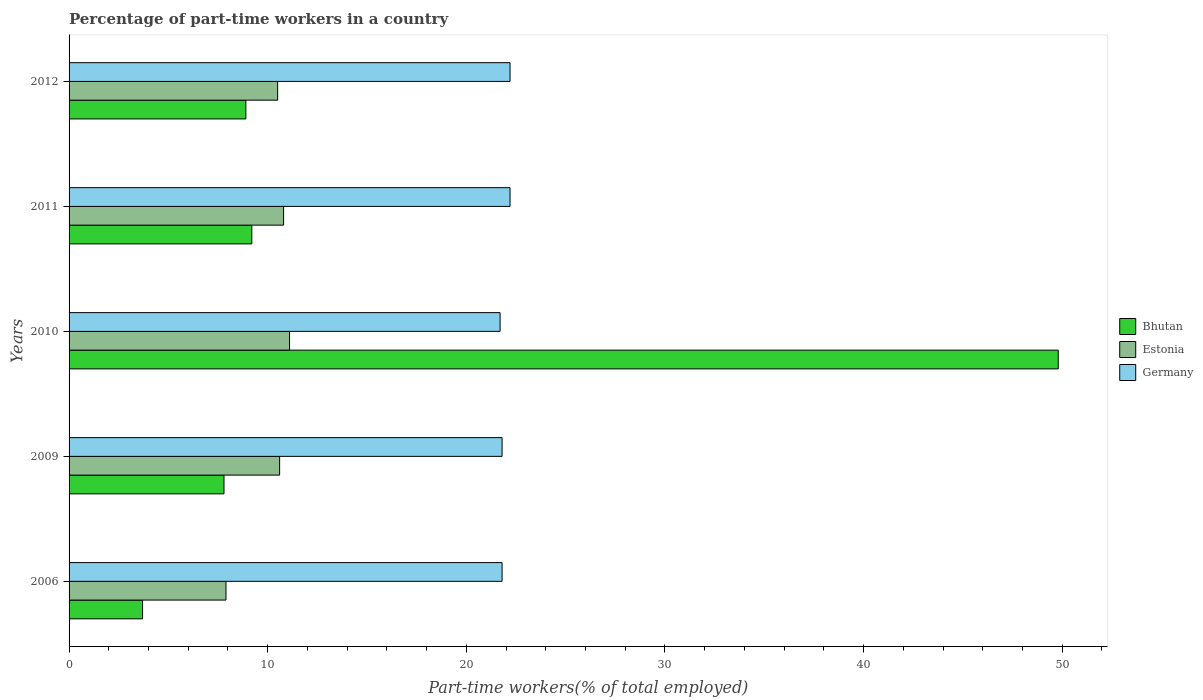How many groups of bars are there?
Make the answer very short. 5. Are the number of bars per tick equal to the number of legend labels?
Offer a very short reply. Yes. Are the number of bars on each tick of the Y-axis equal?
Provide a short and direct response. Yes. How many bars are there on the 2nd tick from the top?
Your answer should be very brief. 3. What is the label of the 3rd group of bars from the top?
Make the answer very short. 2010. What is the percentage of part-time workers in Bhutan in 2009?
Offer a terse response. 7.8. Across all years, what is the maximum percentage of part-time workers in Bhutan?
Make the answer very short. 49.8. Across all years, what is the minimum percentage of part-time workers in Bhutan?
Offer a terse response. 3.7. What is the total percentage of part-time workers in Estonia in the graph?
Offer a very short reply. 50.9. What is the difference between the percentage of part-time workers in Germany in 2010 and that in 2011?
Offer a terse response. -0.5. What is the difference between the percentage of part-time workers in Bhutan in 2006 and the percentage of part-time workers in Germany in 2010?
Provide a succinct answer. -18. What is the average percentage of part-time workers in Bhutan per year?
Your answer should be very brief. 15.88. In the year 2011, what is the difference between the percentage of part-time workers in Bhutan and percentage of part-time workers in Estonia?
Your response must be concise. -1.6. What is the ratio of the percentage of part-time workers in Estonia in 2009 to that in 2012?
Your answer should be very brief. 1.01. Is the percentage of part-time workers in Bhutan in 2009 less than that in 2011?
Offer a very short reply. Yes. What is the difference between the highest and the second highest percentage of part-time workers in Germany?
Provide a succinct answer. 0. What is the difference between the highest and the lowest percentage of part-time workers in Bhutan?
Provide a short and direct response. 46.1. Is the sum of the percentage of part-time workers in Bhutan in 2006 and 2009 greater than the maximum percentage of part-time workers in Germany across all years?
Make the answer very short. No. What does the 2nd bar from the top in 2012 represents?
Provide a succinct answer. Estonia. What does the 3rd bar from the bottom in 2010 represents?
Ensure brevity in your answer.  Germany. Is it the case that in every year, the sum of the percentage of part-time workers in Estonia and percentage of part-time workers in Bhutan is greater than the percentage of part-time workers in Germany?
Ensure brevity in your answer.  No. How many bars are there?
Offer a very short reply. 15. Are all the bars in the graph horizontal?
Provide a short and direct response. Yes. What is the difference between two consecutive major ticks on the X-axis?
Your answer should be very brief. 10. Are the values on the major ticks of X-axis written in scientific E-notation?
Ensure brevity in your answer.  No. Does the graph contain any zero values?
Make the answer very short. No. What is the title of the graph?
Provide a succinct answer. Percentage of part-time workers in a country. Does "Malaysia" appear as one of the legend labels in the graph?
Your response must be concise. No. What is the label or title of the X-axis?
Make the answer very short. Part-time workers(% of total employed). What is the label or title of the Y-axis?
Offer a terse response. Years. What is the Part-time workers(% of total employed) of Bhutan in 2006?
Give a very brief answer. 3.7. What is the Part-time workers(% of total employed) in Estonia in 2006?
Your response must be concise. 7.9. What is the Part-time workers(% of total employed) in Germany in 2006?
Offer a terse response. 21.8. What is the Part-time workers(% of total employed) of Bhutan in 2009?
Make the answer very short. 7.8. What is the Part-time workers(% of total employed) of Estonia in 2009?
Provide a succinct answer. 10.6. What is the Part-time workers(% of total employed) of Germany in 2009?
Offer a terse response. 21.8. What is the Part-time workers(% of total employed) of Bhutan in 2010?
Offer a terse response. 49.8. What is the Part-time workers(% of total employed) of Estonia in 2010?
Provide a succinct answer. 11.1. What is the Part-time workers(% of total employed) in Germany in 2010?
Your response must be concise. 21.7. What is the Part-time workers(% of total employed) of Bhutan in 2011?
Ensure brevity in your answer.  9.2. What is the Part-time workers(% of total employed) in Estonia in 2011?
Your answer should be compact. 10.8. What is the Part-time workers(% of total employed) of Germany in 2011?
Your answer should be very brief. 22.2. What is the Part-time workers(% of total employed) of Bhutan in 2012?
Your answer should be very brief. 8.9. What is the Part-time workers(% of total employed) in Estonia in 2012?
Provide a short and direct response. 10.5. What is the Part-time workers(% of total employed) of Germany in 2012?
Give a very brief answer. 22.2. Across all years, what is the maximum Part-time workers(% of total employed) of Bhutan?
Ensure brevity in your answer.  49.8. Across all years, what is the maximum Part-time workers(% of total employed) in Estonia?
Your answer should be compact. 11.1. Across all years, what is the maximum Part-time workers(% of total employed) in Germany?
Give a very brief answer. 22.2. Across all years, what is the minimum Part-time workers(% of total employed) in Bhutan?
Your answer should be very brief. 3.7. Across all years, what is the minimum Part-time workers(% of total employed) of Estonia?
Provide a succinct answer. 7.9. Across all years, what is the minimum Part-time workers(% of total employed) of Germany?
Make the answer very short. 21.7. What is the total Part-time workers(% of total employed) in Bhutan in the graph?
Your answer should be very brief. 79.4. What is the total Part-time workers(% of total employed) in Estonia in the graph?
Give a very brief answer. 50.9. What is the total Part-time workers(% of total employed) in Germany in the graph?
Ensure brevity in your answer.  109.7. What is the difference between the Part-time workers(% of total employed) in Estonia in 2006 and that in 2009?
Ensure brevity in your answer.  -2.7. What is the difference between the Part-time workers(% of total employed) of Germany in 2006 and that in 2009?
Offer a very short reply. 0. What is the difference between the Part-time workers(% of total employed) in Bhutan in 2006 and that in 2010?
Give a very brief answer. -46.1. What is the difference between the Part-time workers(% of total employed) of Bhutan in 2006 and that in 2011?
Your response must be concise. -5.5. What is the difference between the Part-time workers(% of total employed) of Germany in 2006 and that in 2011?
Make the answer very short. -0.4. What is the difference between the Part-time workers(% of total employed) in Estonia in 2006 and that in 2012?
Provide a succinct answer. -2.6. What is the difference between the Part-time workers(% of total employed) in Bhutan in 2009 and that in 2010?
Make the answer very short. -42. What is the difference between the Part-time workers(% of total employed) of Estonia in 2009 and that in 2010?
Give a very brief answer. -0.5. What is the difference between the Part-time workers(% of total employed) of Germany in 2009 and that in 2010?
Your answer should be very brief. 0.1. What is the difference between the Part-time workers(% of total employed) in Estonia in 2009 and that in 2011?
Provide a short and direct response. -0.2. What is the difference between the Part-time workers(% of total employed) of Germany in 2009 and that in 2011?
Provide a succinct answer. -0.4. What is the difference between the Part-time workers(% of total employed) of Estonia in 2009 and that in 2012?
Keep it short and to the point. 0.1. What is the difference between the Part-time workers(% of total employed) of Germany in 2009 and that in 2012?
Provide a short and direct response. -0.4. What is the difference between the Part-time workers(% of total employed) of Bhutan in 2010 and that in 2011?
Make the answer very short. 40.6. What is the difference between the Part-time workers(% of total employed) in Estonia in 2010 and that in 2011?
Ensure brevity in your answer.  0.3. What is the difference between the Part-time workers(% of total employed) of Bhutan in 2010 and that in 2012?
Keep it short and to the point. 40.9. What is the difference between the Part-time workers(% of total employed) of Germany in 2010 and that in 2012?
Your answer should be compact. -0.5. What is the difference between the Part-time workers(% of total employed) in Estonia in 2011 and that in 2012?
Give a very brief answer. 0.3. What is the difference between the Part-time workers(% of total employed) of Germany in 2011 and that in 2012?
Your response must be concise. 0. What is the difference between the Part-time workers(% of total employed) in Bhutan in 2006 and the Part-time workers(% of total employed) in Germany in 2009?
Your response must be concise. -18.1. What is the difference between the Part-time workers(% of total employed) in Bhutan in 2006 and the Part-time workers(% of total employed) in Germany in 2010?
Offer a terse response. -18. What is the difference between the Part-time workers(% of total employed) in Bhutan in 2006 and the Part-time workers(% of total employed) in Estonia in 2011?
Offer a very short reply. -7.1. What is the difference between the Part-time workers(% of total employed) of Bhutan in 2006 and the Part-time workers(% of total employed) of Germany in 2011?
Provide a succinct answer. -18.5. What is the difference between the Part-time workers(% of total employed) of Estonia in 2006 and the Part-time workers(% of total employed) of Germany in 2011?
Your answer should be very brief. -14.3. What is the difference between the Part-time workers(% of total employed) of Bhutan in 2006 and the Part-time workers(% of total employed) of Germany in 2012?
Provide a short and direct response. -18.5. What is the difference between the Part-time workers(% of total employed) of Estonia in 2006 and the Part-time workers(% of total employed) of Germany in 2012?
Make the answer very short. -14.3. What is the difference between the Part-time workers(% of total employed) in Bhutan in 2009 and the Part-time workers(% of total employed) in Estonia in 2010?
Provide a short and direct response. -3.3. What is the difference between the Part-time workers(% of total employed) of Bhutan in 2009 and the Part-time workers(% of total employed) of Germany in 2010?
Your answer should be compact. -13.9. What is the difference between the Part-time workers(% of total employed) in Bhutan in 2009 and the Part-time workers(% of total employed) in Estonia in 2011?
Provide a succinct answer. -3. What is the difference between the Part-time workers(% of total employed) in Bhutan in 2009 and the Part-time workers(% of total employed) in Germany in 2011?
Your response must be concise. -14.4. What is the difference between the Part-time workers(% of total employed) in Estonia in 2009 and the Part-time workers(% of total employed) in Germany in 2011?
Give a very brief answer. -11.6. What is the difference between the Part-time workers(% of total employed) in Bhutan in 2009 and the Part-time workers(% of total employed) in Germany in 2012?
Provide a succinct answer. -14.4. What is the difference between the Part-time workers(% of total employed) in Bhutan in 2010 and the Part-time workers(% of total employed) in Germany in 2011?
Provide a succinct answer. 27.6. What is the difference between the Part-time workers(% of total employed) of Estonia in 2010 and the Part-time workers(% of total employed) of Germany in 2011?
Keep it short and to the point. -11.1. What is the difference between the Part-time workers(% of total employed) of Bhutan in 2010 and the Part-time workers(% of total employed) of Estonia in 2012?
Offer a very short reply. 39.3. What is the difference between the Part-time workers(% of total employed) in Bhutan in 2010 and the Part-time workers(% of total employed) in Germany in 2012?
Provide a succinct answer. 27.6. What is the difference between the Part-time workers(% of total employed) of Bhutan in 2011 and the Part-time workers(% of total employed) of Germany in 2012?
Provide a short and direct response. -13. What is the average Part-time workers(% of total employed) of Bhutan per year?
Give a very brief answer. 15.88. What is the average Part-time workers(% of total employed) of Estonia per year?
Ensure brevity in your answer.  10.18. What is the average Part-time workers(% of total employed) in Germany per year?
Offer a terse response. 21.94. In the year 2006, what is the difference between the Part-time workers(% of total employed) of Bhutan and Part-time workers(% of total employed) of Germany?
Ensure brevity in your answer.  -18.1. In the year 2009, what is the difference between the Part-time workers(% of total employed) in Bhutan and Part-time workers(% of total employed) in Germany?
Keep it short and to the point. -14. In the year 2009, what is the difference between the Part-time workers(% of total employed) of Estonia and Part-time workers(% of total employed) of Germany?
Provide a succinct answer. -11.2. In the year 2010, what is the difference between the Part-time workers(% of total employed) of Bhutan and Part-time workers(% of total employed) of Estonia?
Give a very brief answer. 38.7. In the year 2010, what is the difference between the Part-time workers(% of total employed) of Bhutan and Part-time workers(% of total employed) of Germany?
Provide a short and direct response. 28.1. In the year 2010, what is the difference between the Part-time workers(% of total employed) of Estonia and Part-time workers(% of total employed) of Germany?
Provide a succinct answer. -10.6. In the year 2011, what is the difference between the Part-time workers(% of total employed) of Bhutan and Part-time workers(% of total employed) of Estonia?
Your response must be concise. -1.6. In the year 2011, what is the difference between the Part-time workers(% of total employed) in Estonia and Part-time workers(% of total employed) in Germany?
Provide a short and direct response. -11.4. In the year 2012, what is the difference between the Part-time workers(% of total employed) in Bhutan and Part-time workers(% of total employed) in Estonia?
Offer a very short reply. -1.6. In the year 2012, what is the difference between the Part-time workers(% of total employed) of Estonia and Part-time workers(% of total employed) of Germany?
Provide a succinct answer. -11.7. What is the ratio of the Part-time workers(% of total employed) of Bhutan in 2006 to that in 2009?
Make the answer very short. 0.47. What is the ratio of the Part-time workers(% of total employed) of Estonia in 2006 to that in 2009?
Ensure brevity in your answer.  0.75. What is the ratio of the Part-time workers(% of total employed) in Germany in 2006 to that in 2009?
Offer a terse response. 1. What is the ratio of the Part-time workers(% of total employed) of Bhutan in 2006 to that in 2010?
Ensure brevity in your answer.  0.07. What is the ratio of the Part-time workers(% of total employed) of Estonia in 2006 to that in 2010?
Make the answer very short. 0.71. What is the ratio of the Part-time workers(% of total employed) of Germany in 2006 to that in 2010?
Your answer should be very brief. 1. What is the ratio of the Part-time workers(% of total employed) in Bhutan in 2006 to that in 2011?
Provide a succinct answer. 0.4. What is the ratio of the Part-time workers(% of total employed) in Estonia in 2006 to that in 2011?
Provide a short and direct response. 0.73. What is the ratio of the Part-time workers(% of total employed) in Bhutan in 2006 to that in 2012?
Make the answer very short. 0.42. What is the ratio of the Part-time workers(% of total employed) of Estonia in 2006 to that in 2012?
Provide a succinct answer. 0.75. What is the ratio of the Part-time workers(% of total employed) of Germany in 2006 to that in 2012?
Ensure brevity in your answer.  0.98. What is the ratio of the Part-time workers(% of total employed) of Bhutan in 2009 to that in 2010?
Offer a terse response. 0.16. What is the ratio of the Part-time workers(% of total employed) in Estonia in 2009 to that in 2010?
Provide a short and direct response. 0.95. What is the ratio of the Part-time workers(% of total employed) of Germany in 2009 to that in 2010?
Offer a terse response. 1. What is the ratio of the Part-time workers(% of total employed) of Bhutan in 2009 to that in 2011?
Provide a short and direct response. 0.85. What is the ratio of the Part-time workers(% of total employed) of Estonia in 2009 to that in 2011?
Provide a short and direct response. 0.98. What is the ratio of the Part-time workers(% of total employed) in Bhutan in 2009 to that in 2012?
Ensure brevity in your answer.  0.88. What is the ratio of the Part-time workers(% of total employed) of Estonia in 2009 to that in 2012?
Provide a succinct answer. 1.01. What is the ratio of the Part-time workers(% of total employed) of Germany in 2009 to that in 2012?
Offer a terse response. 0.98. What is the ratio of the Part-time workers(% of total employed) of Bhutan in 2010 to that in 2011?
Offer a very short reply. 5.41. What is the ratio of the Part-time workers(% of total employed) of Estonia in 2010 to that in 2011?
Give a very brief answer. 1.03. What is the ratio of the Part-time workers(% of total employed) of Germany in 2010 to that in 2011?
Your answer should be compact. 0.98. What is the ratio of the Part-time workers(% of total employed) of Bhutan in 2010 to that in 2012?
Your answer should be very brief. 5.6. What is the ratio of the Part-time workers(% of total employed) of Estonia in 2010 to that in 2012?
Give a very brief answer. 1.06. What is the ratio of the Part-time workers(% of total employed) in Germany in 2010 to that in 2012?
Your answer should be compact. 0.98. What is the ratio of the Part-time workers(% of total employed) of Bhutan in 2011 to that in 2012?
Ensure brevity in your answer.  1.03. What is the ratio of the Part-time workers(% of total employed) of Estonia in 2011 to that in 2012?
Give a very brief answer. 1.03. What is the difference between the highest and the second highest Part-time workers(% of total employed) of Bhutan?
Provide a succinct answer. 40.6. What is the difference between the highest and the second highest Part-time workers(% of total employed) in Estonia?
Your answer should be very brief. 0.3. What is the difference between the highest and the second highest Part-time workers(% of total employed) in Germany?
Provide a succinct answer. 0. What is the difference between the highest and the lowest Part-time workers(% of total employed) of Bhutan?
Your answer should be compact. 46.1. What is the difference between the highest and the lowest Part-time workers(% of total employed) of Estonia?
Ensure brevity in your answer.  3.2. 